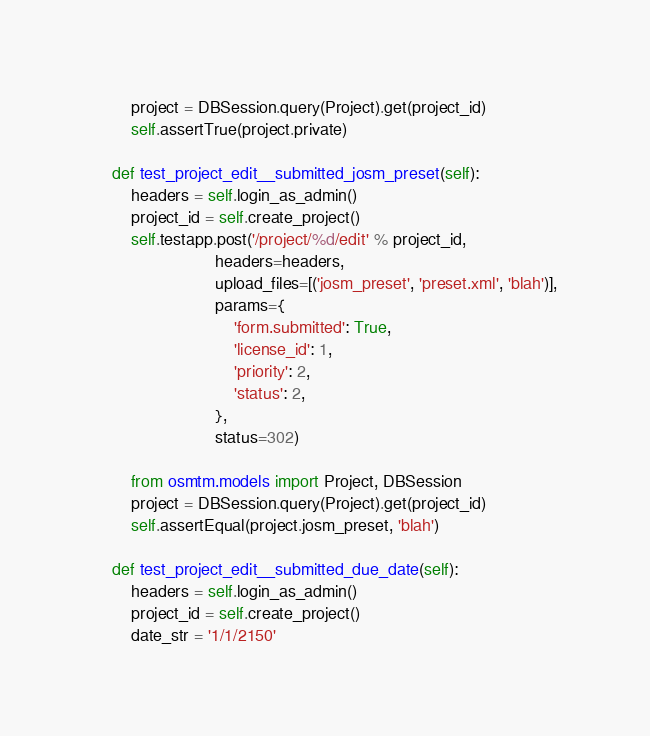<code> <loc_0><loc_0><loc_500><loc_500><_Python_>        project = DBSession.query(Project).get(project_id)
        self.assertTrue(project.private)

    def test_project_edit__submitted_josm_preset(self):
        headers = self.login_as_admin()
        project_id = self.create_project()
        self.testapp.post('/project/%d/edit' % project_id,
                          headers=headers,
                          upload_files=[('josm_preset', 'preset.xml', 'blah')],
                          params={
                              'form.submitted': True,
                              'license_id': 1,
                              'priority': 2,
                              'status': 2,
                          },
                          status=302)

        from osmtm.models import Project, DBSession
        project = DBSession.query(Project).get(project_id)
        self.assertEqual(project.josm_preset, 'blah')

    def test_project_edit__submitted_due_date(self):
        headers = self.login_as_admin()
        project_id = self.create_project()
        date_str = '1/1/2150'</code> 